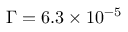Convert formula to latex. <formula><loc_0><loc_0><loc_500><loc_500>\Gamma = 6 . 3 \times 1 0 ^ { - 5 }</formula> 